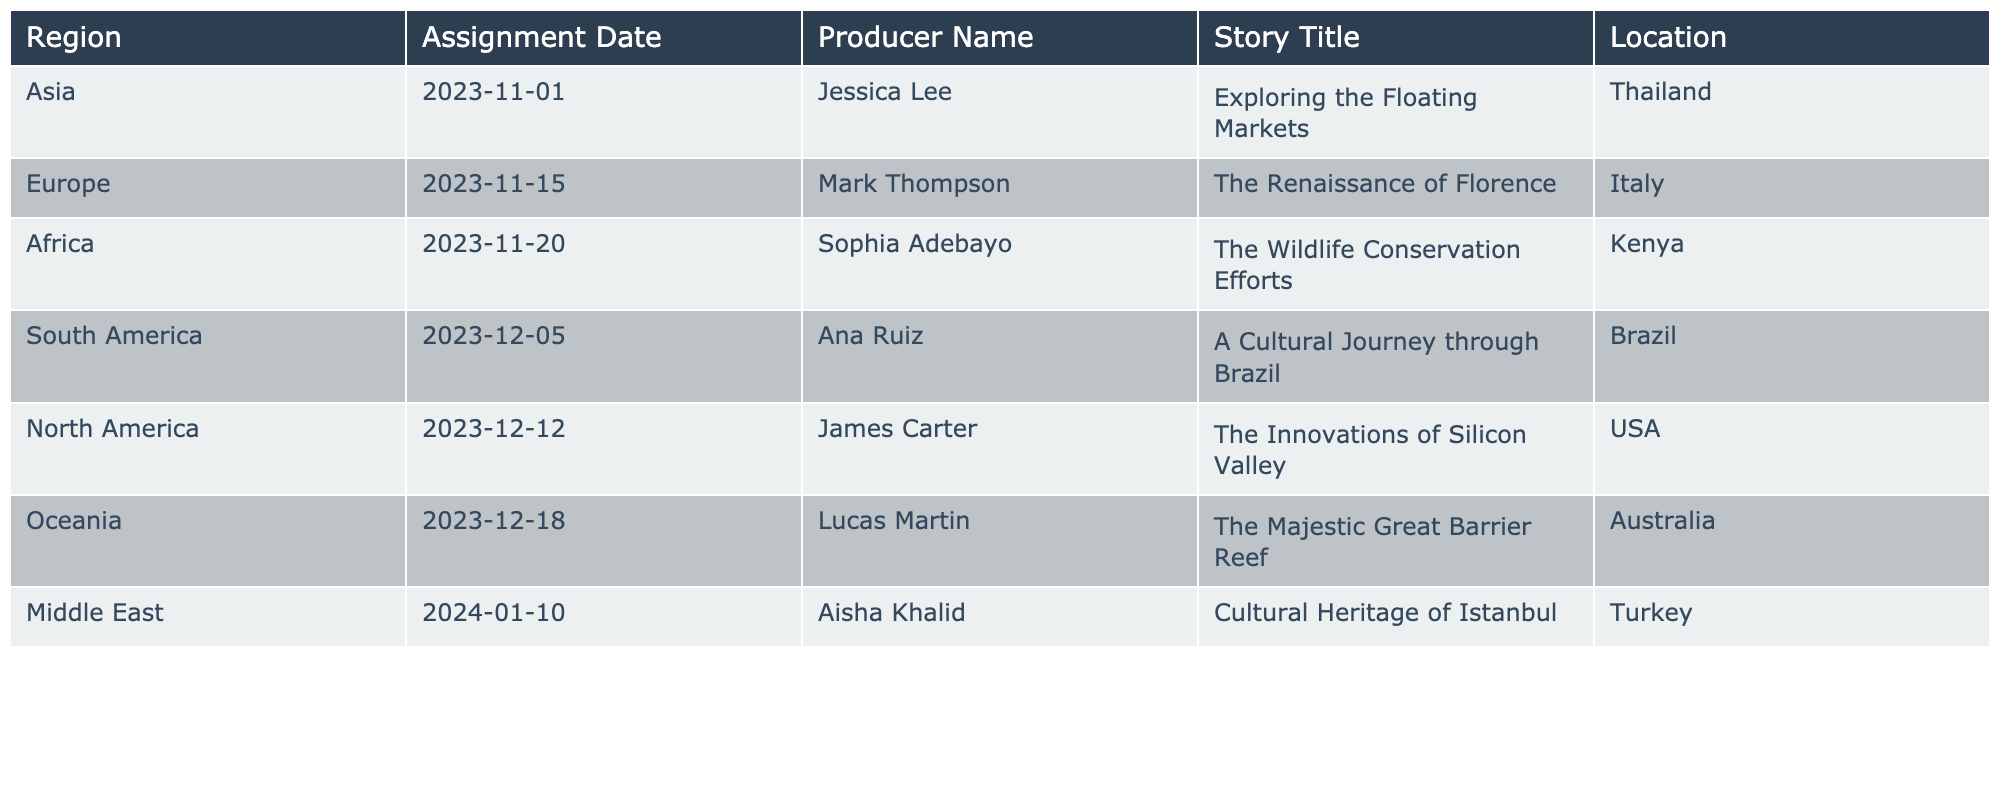What is the location of the assignment titled "The Innovations of Silicon Valley"? The title "The Innovations of Silicon Valley" is associated with the North America region, and the location listed for this assignment is the USA.
Answer: USA Who is the producer for the assignment on wildlife conservation efforts? The assignment titled "The Wildlife Conservation Efforts" is produced by Sophia Adebayo.
Answer: Sophia Adebayo Which region has an assignment scheduled for December 18, 2023? The assignment scheduled for December 18, 2023, is in the Oceania region, specifically for the story about the Great Barrier Reef.
Answer: Oceania Is there an assignment related to cultural heritage? Yes, there is an assignment titled "Cultural Heritage of Istanbul" scheduled for January 10, 2024, in the Middle East region.
Answer: Yes What is the earliest assignment date and its corresponding region? The earliest assignment date is November 1, 2023, which corresponds to the Asia region for the title "Exploring the Floating Markets."
Answer: Asia Which producer has the most assignments scheduled in 2023? By reviewing the assignments in 2023, it appears that no producer has more than one scheduled assignment; therefore, each producer has an equal number of assignments.
Answer: No producer has more than one assignment How many assignments are scheduled for the month of December? There are three assignments scheduled in December: one for South America on the 5th, one for North America on the 12th, and one for Oceania on the 18th, totaling three.
Answer: Three If we consider all producers for the table, who has assignments beyond 2023? Aisha Khalid is the only producer with an assignment in 2024, titled "Cultural Heritage of Istanbul."
Answer: Aisha Khalid Which region has the latest assignment date? The latest assignment date is January 10, 2024, in the Middle East region.
Answer: Middle East What title corresponds to the assignment scheduled for November 15, 2023? The assignment scheduled for November 15, 2023, is titled "The Renaissance of Florence," taking place in Italy.
Answer: The Renaissance of Florence 